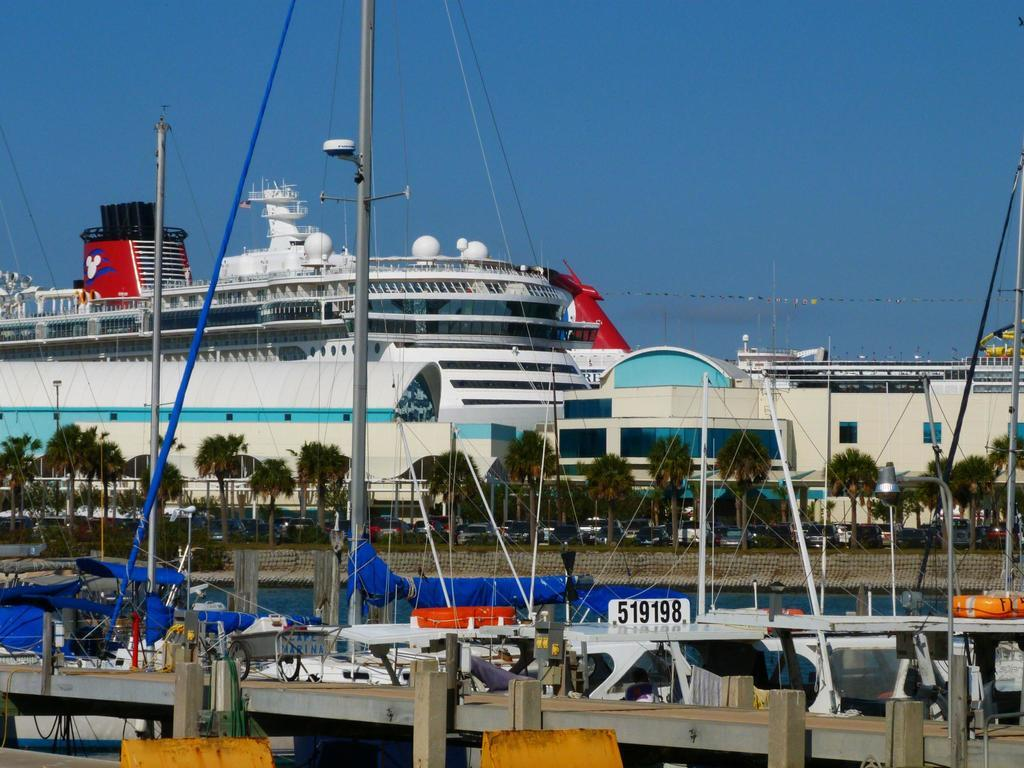What type of vegetation is located in the middle of the image? There are trees in the middle of the image. What structure can also be seen in the middle of the image? There appears to be a building in the middle of the image. What can be seen in the background of the image? Ships are visible in the background of the image. What is visible at the top of the image? The sky is visible at the top of the image. Where is the garden located in the image? There is no garden present in the image. What type of meal is being prepared in the room in the image? There is no room or meal present in the image. 